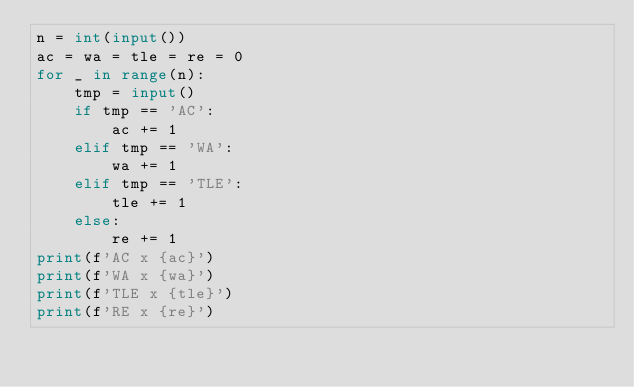<code> <loc_0><loc_0><loc_500><loc_500><_Python_>n = int(input())
ac = wa = tle = re = 0
for _ in range(n):
    tmp = input()
    if tmp == 'AC':
        ac += 1
    elif tmp == 'WA':
        wa += 1
    elif tmp == 'TLE':
        tle += 1
    else:
        re += 1
print(f'AC x {ac}')
print(f'WA x {wa}')
print(f'TLE x {tle}')
print(f'RE x {re}')</code> 